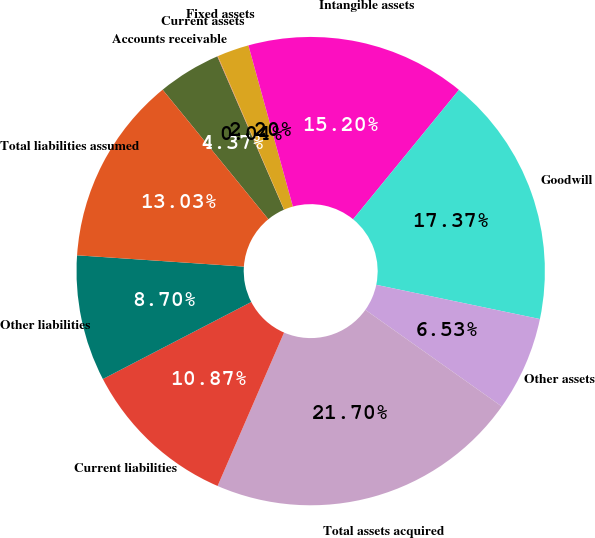Convert chart to OTSL. <chart><loc_0><loc_0><loc_500><loc_500><pie_chart><fcel>Accounts receivable<fcel>Current assets<fcel>Fixed assets<fcel>Intangible assets<fcel>Goodwill<fcel>Other assets<fcel>Total assets acquired<fcel>Current liabilities<fcel>Other liabilities<fcel>Total liabilities assumed<nl><fcel>4.37%<fcel>0.04%<fcel>2.2%<fcel>15.2%<fcel>17.37%<fcel>6.53%<fcel>21.7%<fcel>10.87%<fcel>8.7%<fcel>13.03%<nl></chart> 